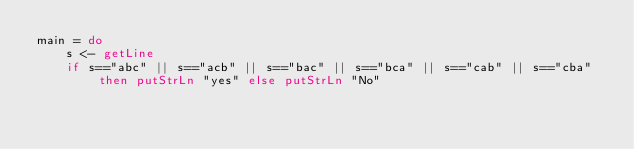<code> <loc_0><loc_0><loc_500><loc_500><_Haskell_>main = do
    s <- getLine
    if s=="abc" || s=="acb" || s=="bac" || s=="bca" || s=="cab" || s=="cba" then putStrLn "yes" else putStrLn "No"</code> 